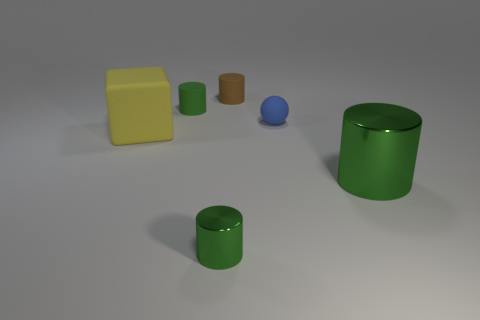Is the shape of the tiny green thing in front of the tiny ball the same as  the green matte object?
Provide a succinct answer. Yes. Are there any other things of the same color as the big metal cylinder?
Your response must be concise. Yes. There is a yellow thing that is made of the same material as the blue thing; what is its size?
Your response must be concise. Large. What is the material of the yellow cube to the left of the object behind the green cylinder that is behind the matte sphere?
Give a very brief answer. Rubber. Is the number of blue rubber spheres less than the number of small red shiny things?
Give a very brief answer. No. Are the large cube and the large green object made of the same material?
Offer a very short reply. No. There is a large object that is the same color as the tiny shiny object; what shape is it?
Provide a succinct answer. Cylinder. There is a metal object that is left of the large green thing; does it have the same color as the big cylinder?
Your answer should be very brief. Yes. What number of tiny balls are on the left side of the large block that is to the left of the large green object?
Keep it short and to the point. 0. What color is the matte sphere that is the same size as the brown matte cylinder?
Offer a very short reply. Blue. 